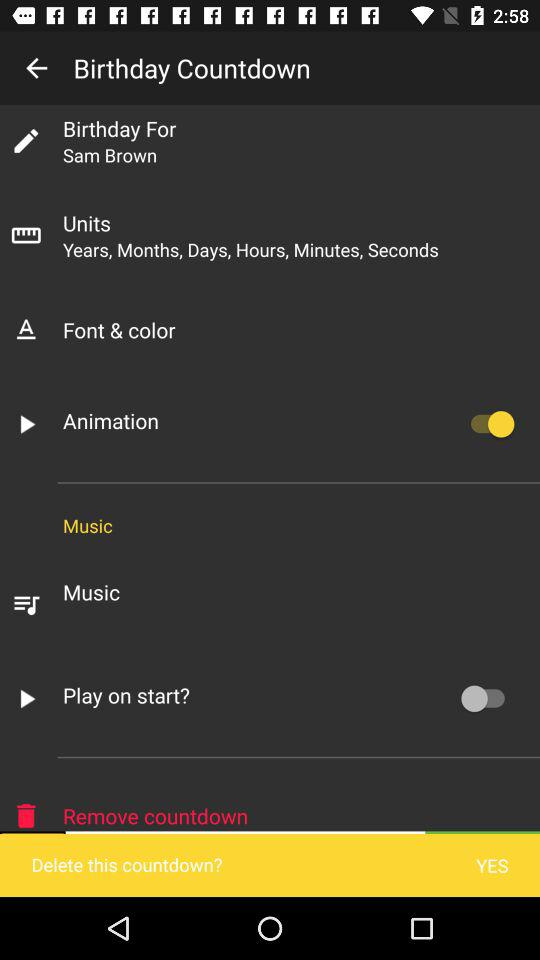Which option is switched on? The option that is switched on is "Animation". 